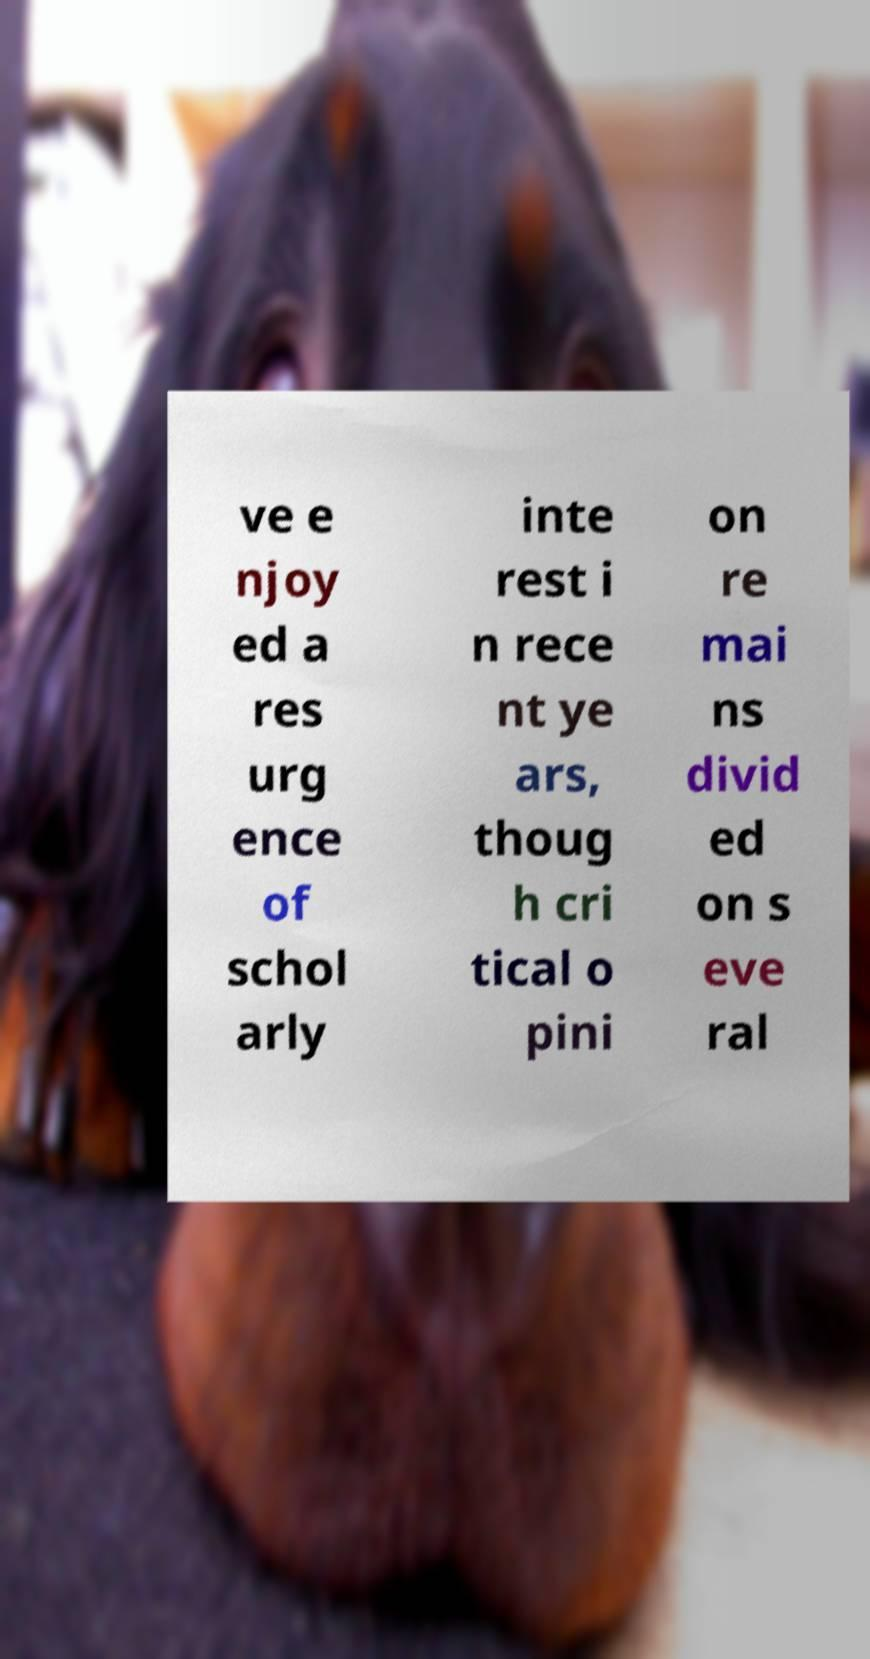Could you extract and type out the text from this image? ve e njoy ed a res urg ence of schol arly inte rest i n rece nt ye ars, thoug h cri tical o pini on re mai ns divid ed on s eve ral 